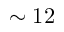Convert formula to latex. <formula><loc_0><loc_0><loc_500><loc_500>\sim 1 2</formula> 